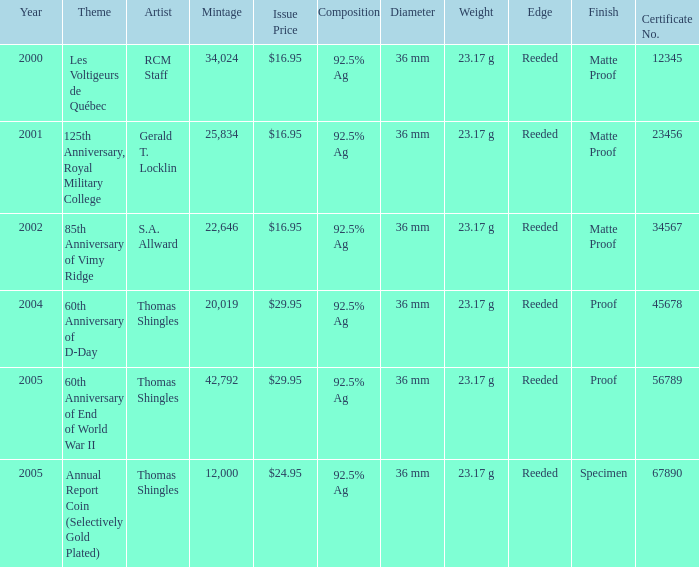What year was S.A. Allward's theme that had an issue price of $16.95 released? 2002.0. 